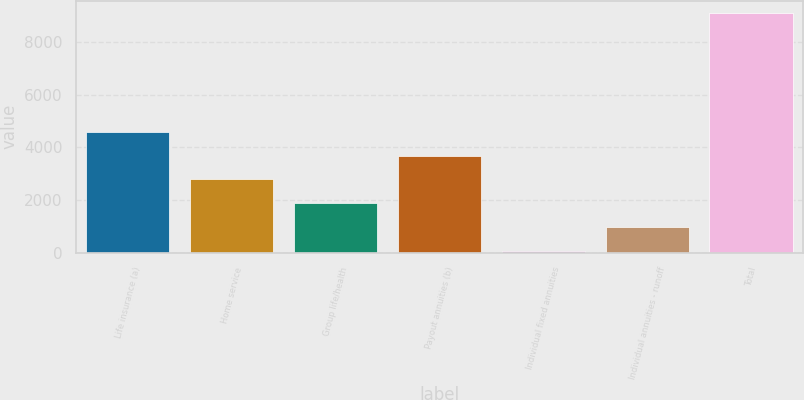<chart> <loc_0><loc_0><loc_500><loc_500><bar_chart><fcel>Life insurance (a)<fcel>Home service<fcel>Group life/health<fcel>Payout annuities (b)<fcel>Individual fixed annuities<fcel>Individual annuities - runoff<fcel>Total<nl><fcel>4589.5<fcel>2782.9<fcel>1879.6<fcel>3686.2<fcel>73<fcel>976.3<fcel>9106<nl></chart> 